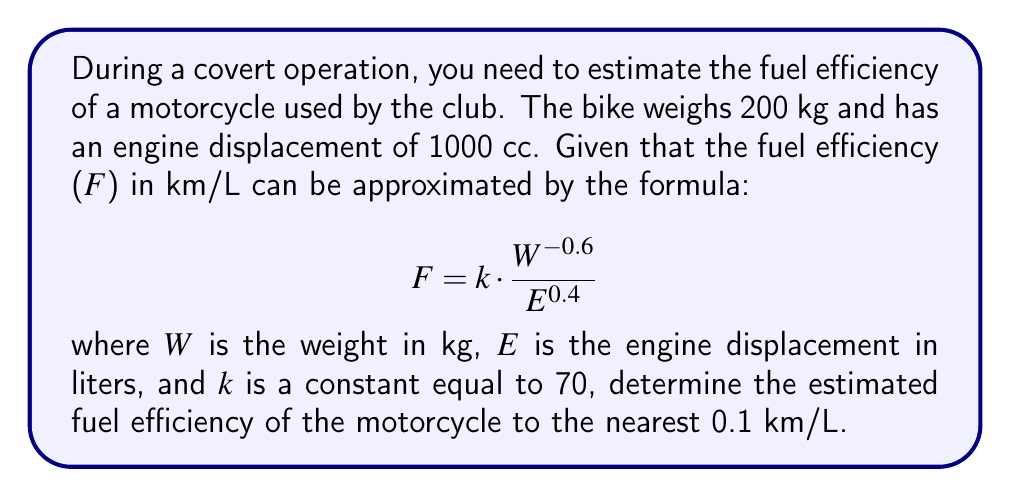Teach me how to tackle this problem. To solve this problem, we'll follow these steps:

1) First, let's identify the given values:
   - Weight (W) = 200 kg
   - Engine displacement (E) = 1000 cc = 1 L
   - Constant (k) = 70

2) We need to use the formula:
   $$ F = k \cdot \frac{W^{-0.6}}{E^{0.4}} $$

3) Let's substitute the values:
   $$ F = 70 \cdot \frac{200^{-0.6}}{1^{0.4}} $$

4) Simplify:
   $$ F = 70 \cdot \frac{1}{200^{0.6}} $$

5) Calculate $200^{0.6}$:
   $200^{0.6} \approx 21.5443$

6) Now our equation looks like:
   $$ F = 70 \cdot \frac{1}{21.5443} $$

7) Divide:
   $$ F \approx 3.2492 $$

8) Rounding to the nearest 0.1:
   $$ F \approx 3.2 \text{ km/L} $$
Answer: 3.2 km/L 